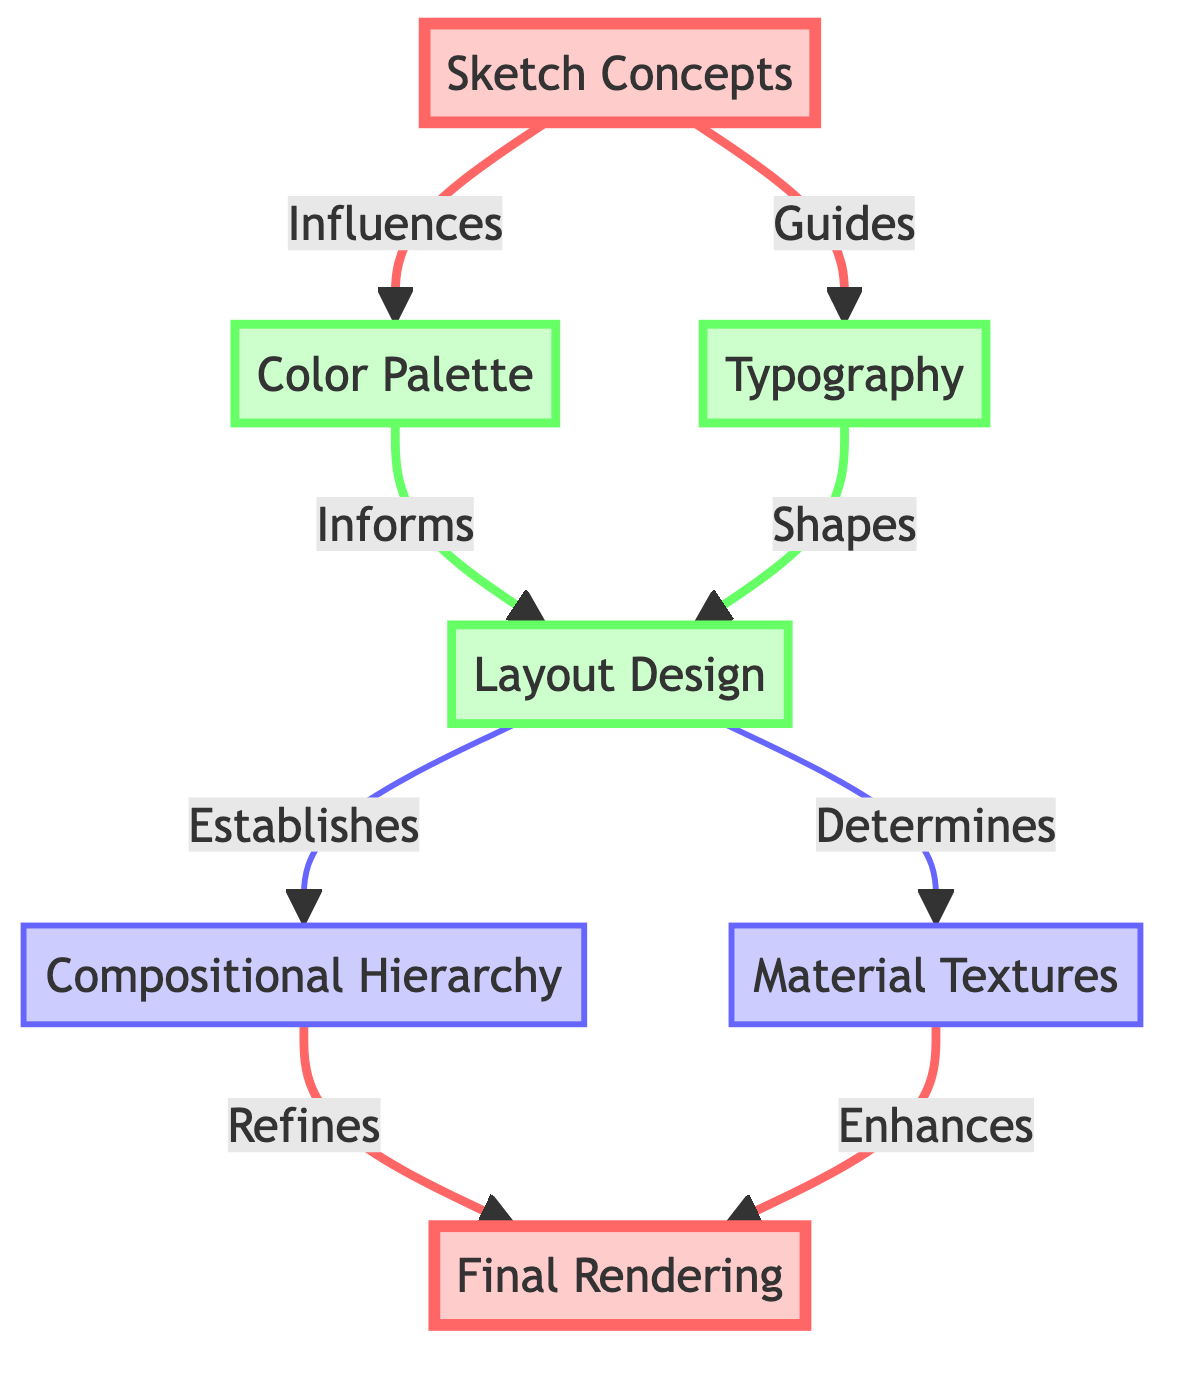What is the highest level node in the diagram? The highest level node is determined by identifying nodes that do not have any outgoing edges leading to other nodes. In this diagram, "Final Rendering" has incoming connections from "Compositional Hierarchy" and "Material Textures" but does not lead to any other nodes, making it the highest level node.
Answer: Final Rendering How many nodes are present in the diagram? To determine the number of nodes, we count each unique node present in the diagram data. The nodes are Sketch Concepts, Color Palette, Typography, Layout Design, Material Textures, Compositional Hierarchy, and Final Rendering. This gives a total of 7 distinct nodes.
Answer: 7 What relationship connects "Typography" and "Layout Design"? The relationship between "Typography" and "Layout Design" can be identified by analyzing the edge that originates from "Typography" and ends at "Layout Design." The graph specifies that Typography shapes Layout Design, indicating this specific relationship.
Answer: Shapes Which node directly influences "Color Palette"? To find which node influences "Color Palette," we look for the incoming edges. We can see that "Sketch Concepts" directly connects to "Color Palette," specifying that it influences this element in the design hierarchy.
Answer: Sketch Concepts What is the lowest level node in the diagram? The lowest level node is defined as the node that does not lead to any further nodes. In this diagram, both "Material Textures" and "Compositional Hierarchy" are at the same level and lead to "Final Rendering," but they do not influence any additional nodes themselves, identifying them as the lowest-level nodes.
Answer: Material Textures, Compositional Hierarchy How many edges are present in the diagram? The number of edges can be found by counting the connections specified between nodes. Every directed connection counts as one edge. In this data, there are a total of 8 edges linking the nodes.
Answer: 8 Which element impacts "Final Rendering" the most? To determine the element that impacts "Final Rendering," we should trace the connections leading into "Final Rendering." Both "Compositional Hierarchy" and "Material Textures" have direct edges to "Final Rendering"; therefore, both elements impact it equally, but "Compositional Hierarchy" specifically refines the final output.
Answer: Compositional Hierarchy What is the primary function of "Layout Design"? We can ascertain the primary function of "Layout Design" by looking at its connections. "Layout Design" receives influence from both "Color Palette" and "Typography," and it also determines "Material Textures" and establishes "Compositional Hierarchy." Hence, it serves as a critical hub in the design process.
Answer: Determines and Establishes 